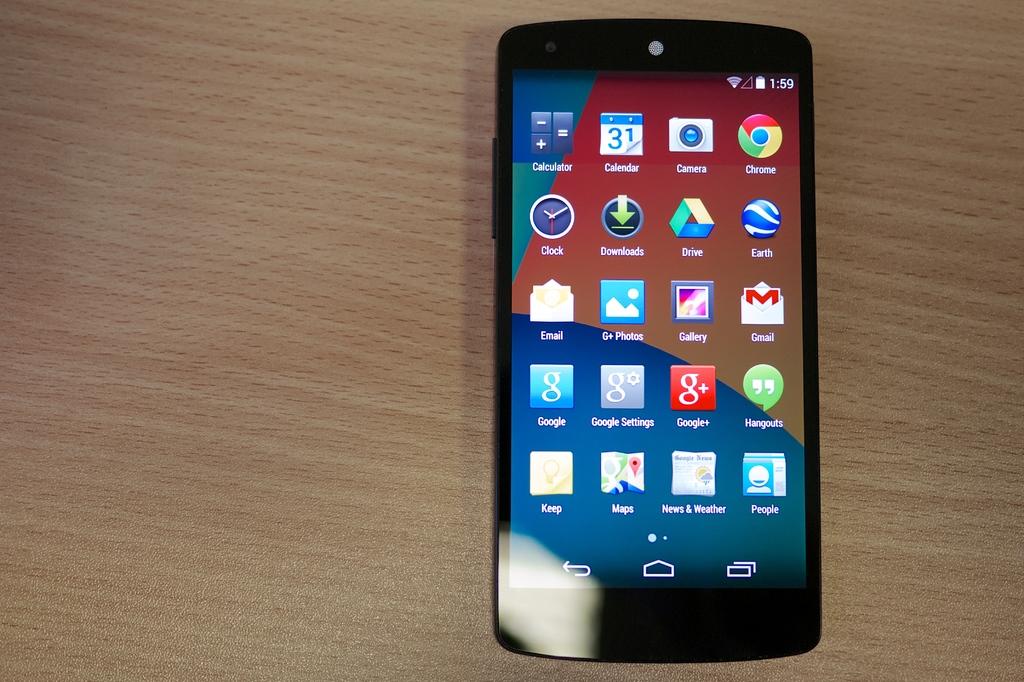What is the name of the app with the downward facing green arrow?
Your answer should be very brief. Downloads. 